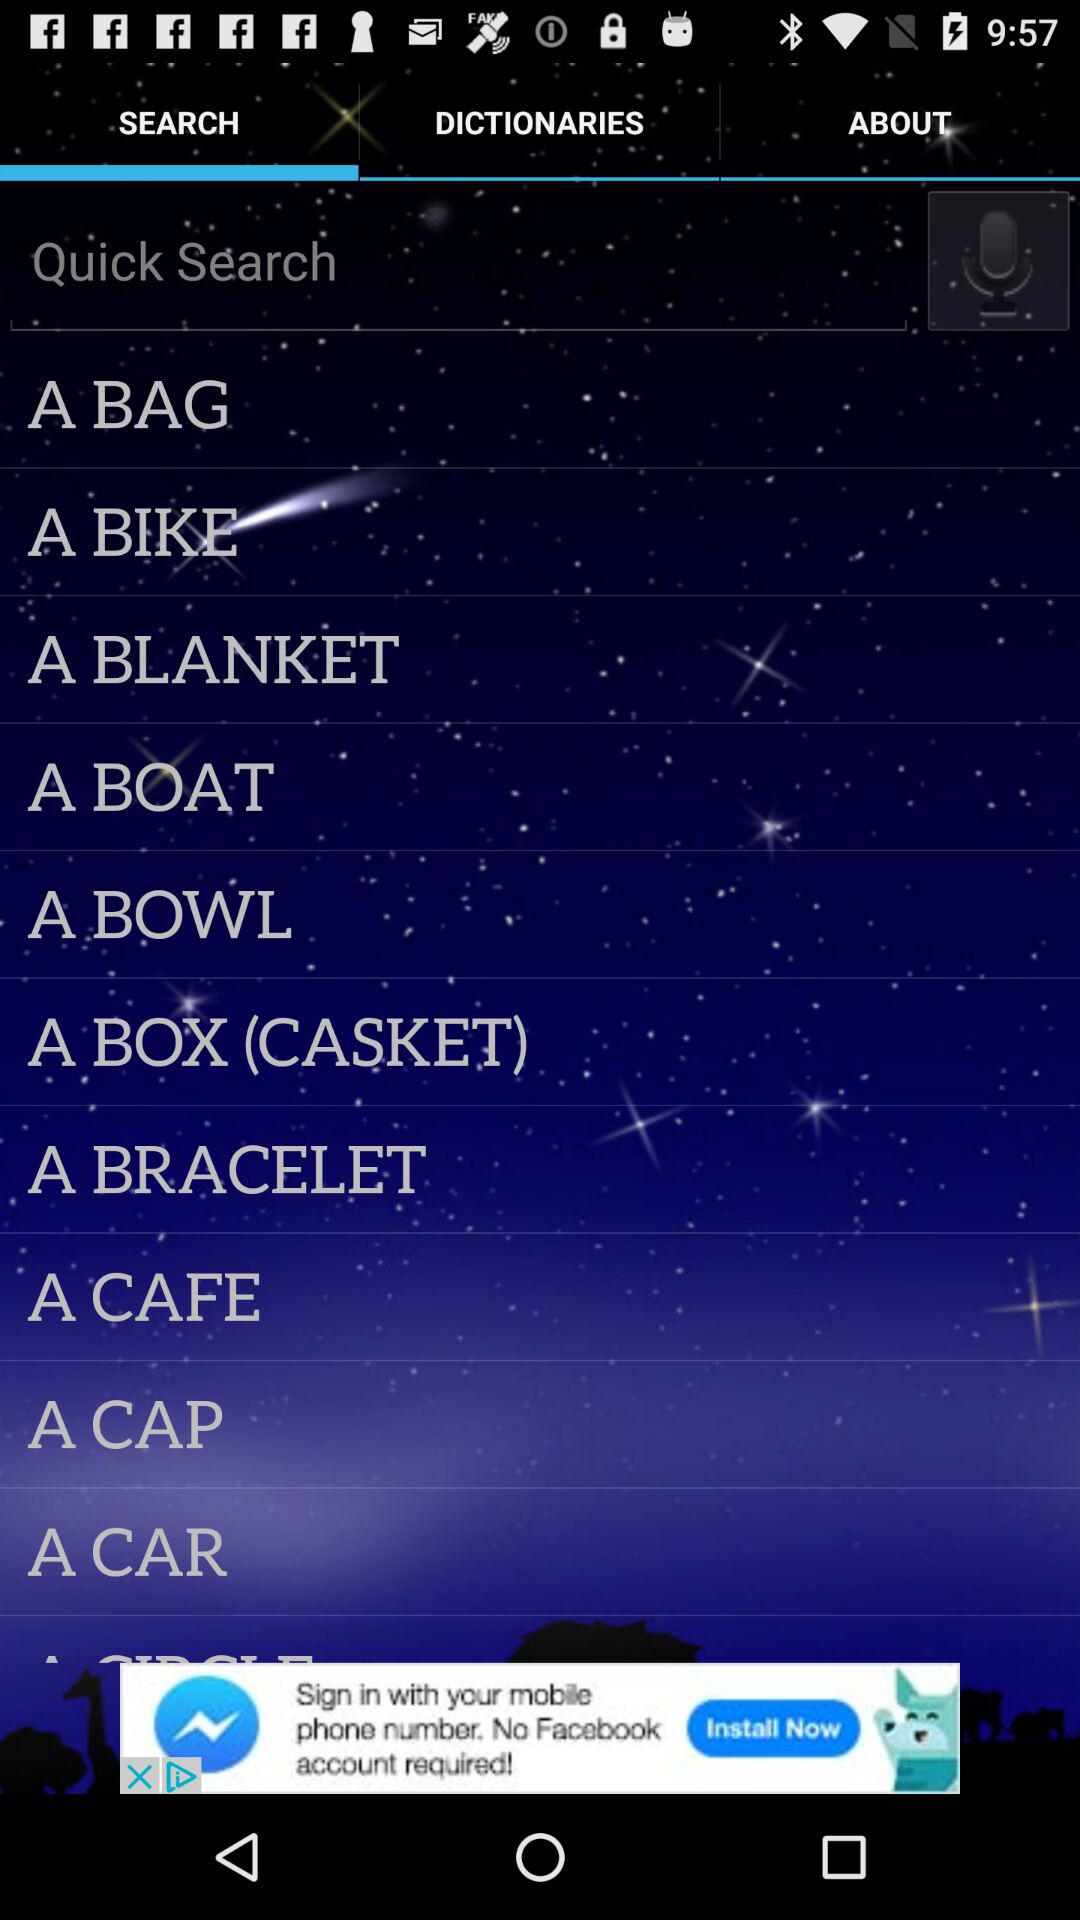What is the selected tab? The selected tab is "SEARCH". 